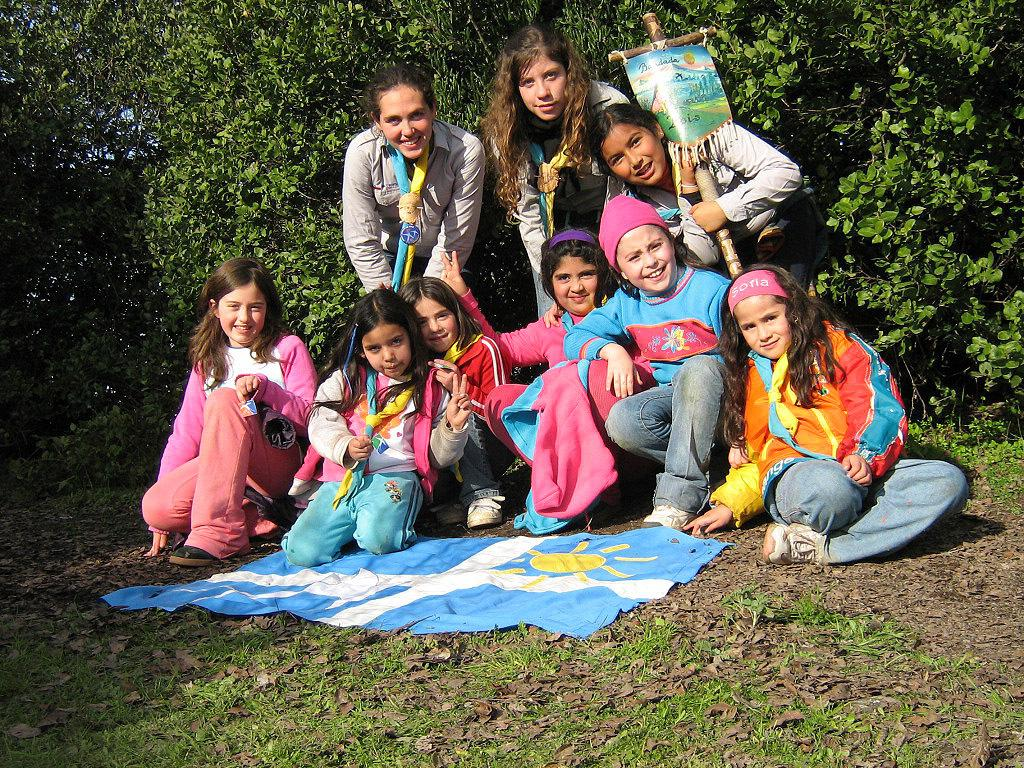How many people are in the image? There are people in the image, but the exact number is not specified. What are some of the people holding in the image? Some of the people are holding objects, but the specific objects are not mentioned. What type of vegetation is visible in the image? Grass and leaves are present in the image. What is the cloth on the ground used for? The purpose of the cloth on the ground is not specified. What can be seen in the background of the image? There are trees in the background of the image. What type of bomb can be seen in the image? There is no bomb present in the image. How many pails are visible in the image? The facts do not mention any pails, so we cannot determine if any are visible in the image. 